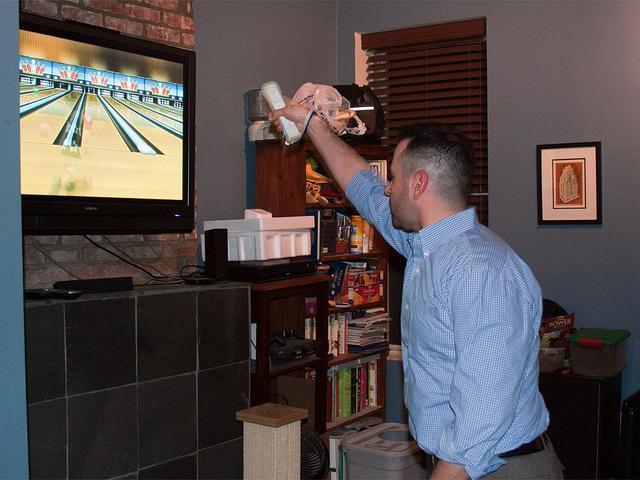How many clock faces are there?
Give a very brief answer. 0. 